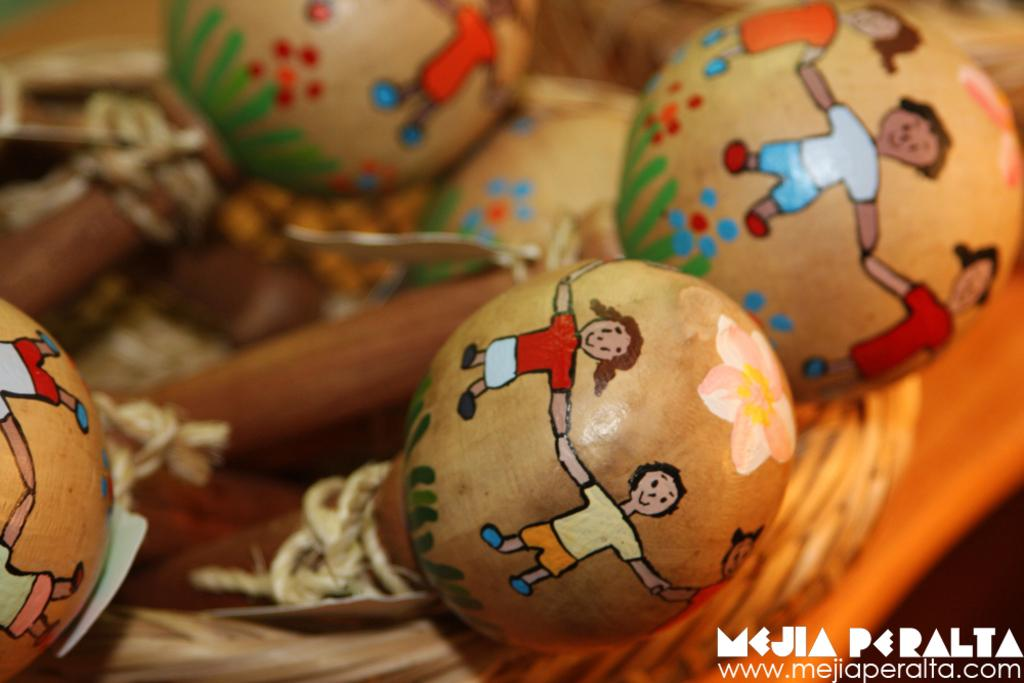What type of musical instruments are featured in the image? There are maracas with paintings on them in the image. How are the maracas arranged or stored in the image? The maracas are in a basket. Can you describe the background of the image? The background of the image is blurred. Is there any additional information or marking on the image itself? Yes, there is a watermark on the image. What type of crime is being committed in the image? There is no crime depicted in the image; it features maracas in a basket. 